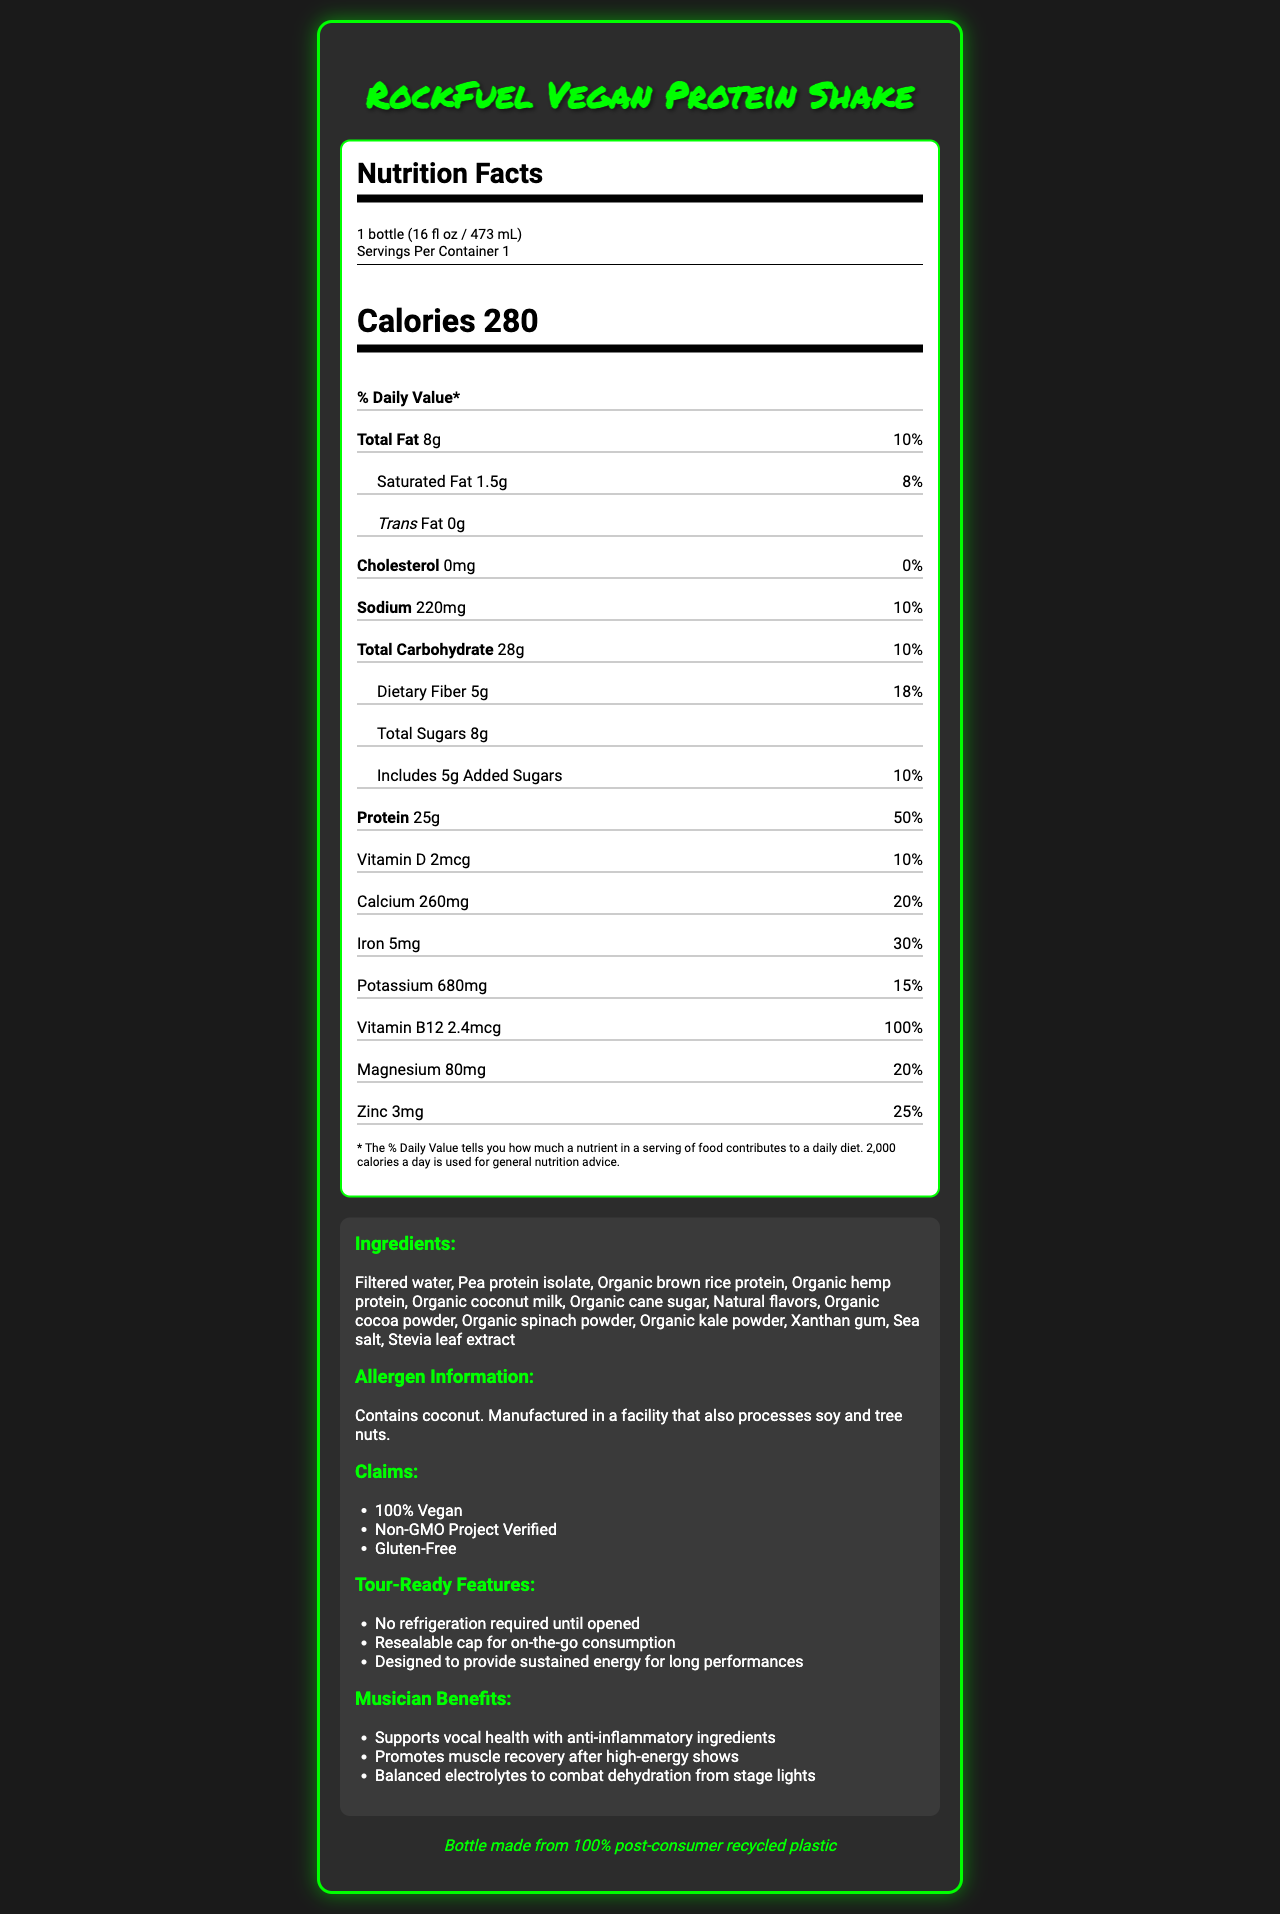what is the serving size of RockFuel Vegan Protein Shake? The serving size is clearly stated in the serving information section of the Nutrition Facts Label.
Answer: 1 bottle (16 fl oz / 473 mL) how many calories are in one serving of this shake? The number of calories per serving is prominently displayed in the middle of the Nutrition Facts Label.
Answer: 280 What is the total amount of protein in one serving? The amount of protein per serving is listed under the protein section in the Nutrition Facts Label.
Answer: 25g what is the daily value percentage for dietary fiber? The daily value percentage for dietary fiber is given in parentheses next to its amount.
Answer: 18% name three protein sources included in the ingredients. These ingredients are specified in the list under the "Ingredients" section.
Answer: Pea protein isolate, Organic brown rice protein, Organic hemp protein what is the amount of added sugars in one serving? A. 0g B. 2.5g C. 5g D. 8g The amount of added sugars is listed as 5g under the sugars category.
Answer: C. 5g what are the allergen warnings mentioned? A. Contains soy and tree nuts B. Contains coconut and manufactured in a facility that processes soy and tree nuts C. Contains dairy and gluten The allergen information mentions that it contains coconut and is manufactured in a facility that processes soy and tree nuts.
Answer: B. Contains coconut and manufactured in a facility that processes soy and tree nuts how much calcium is in one serving of this shake? The amount of calcium is listed under the vitamin and minerals section of the Nutrition Facts Label.
Answer: 260mg does this product contain any cholesterol? The cholesterol amount is clearly listed as 0mg and 0% daily value.
Answer: No is RockFuel Vegan Protein Shake suitable for vegans? The product claims to be "100% Vegan."
Answer: Yes summarize the main features of the RockFuel Vegan Protein Shake. This summary captures the key points about the product's nutritional content, ingredients, special claims, and benefits for musicians on tour.
Answer: The RockFuel Vegan Protein Shake is a high-protein, plant-based meal replacement designed for musicians on tour. It contains 280 calories per serving with 25g of protein, and includes ingredients like pea protein isolate, organic brown rice protein, and organic hemp protein. It provides several nutritional benefits and is vegan, gluten-free, and non-GMO. The shake is tour-ready with no refrigeration required until opened, boasts anti-inflammatory and muscle recovery benefits, and comes in eco-friendly packaging. how much Vitamin D is included in a serving of this shake? The amount of Vitamin D is listed under the vitamin and minerals section with its respective daily value.
Answer: 2mcg which nutrient has the highest daily value percentage? The protein has the highest daily value percentage listed as 50%.
Answer: Protein does this shake provide any benefits for vocal health? The document mentions that it supports vocal health with anti-inflammatory ingredients.
Answer: Yes how many servings are in one container? The serving information specifies that there is one serving per container.
Answer: 1 what are the main carbohydrates sources listed in the ingredients? These are mentioned in the ingredients section, providing clues about carbohydrate sources in the product.
Answer: Organic cane sugar, Organic cocoa powder can this document tell us the exact price of the RockFuel Vegan Protein Shake? The document provides nutrition facts and product features but does not include pricing information.
Answer: Not enough information 